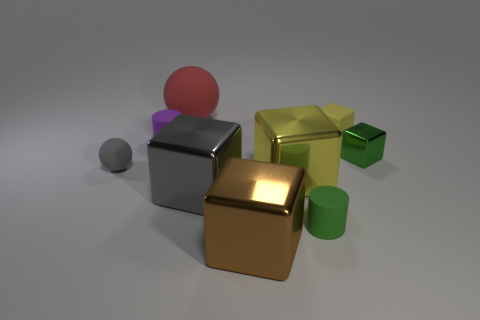Does the gray metallic object have the same size as the cylinder that is right of the big brown metal block?
Provide a succinct answer. No. There is a shiny cube that is left of the brown object; does it have the same size as the green thing to the right of the small rubber cube?
Make the answer very short. No. There is a small object that is the same color as the small metallic block; what material is it?
Give a very brief answer. Rubber. There is a green object to the right of the matte cylinder right of the yellow metal block; are there any gray rubber objects on the left side of it?
Provide a succinct answer. Yes. Is the material of the small green object behind the gray metal thing the same as the cylinder that is in front of the gray matte ball?
Your response must be concise. No. How many objects are yellow rubber things or small things right of the red ball?
Give a very brief answer. 3. What number of green metal objects have the same shape as the big brown shiny thing?
Provide a short and direct response. 1. There is a green cube that is the same size as the gray ball; what is it made of?
Provide a succinct answer. Metal. What size is the rubber thing in front of the ball that is in front of the rubber sphere that is behind the purple cylinder?
Your answer should be compact. Small. Does the rubber cylinder to the right of the big matte object have the same color as the metal cube to the right of the tiny green matte thing?
Keep it short and to the point. Yes. 